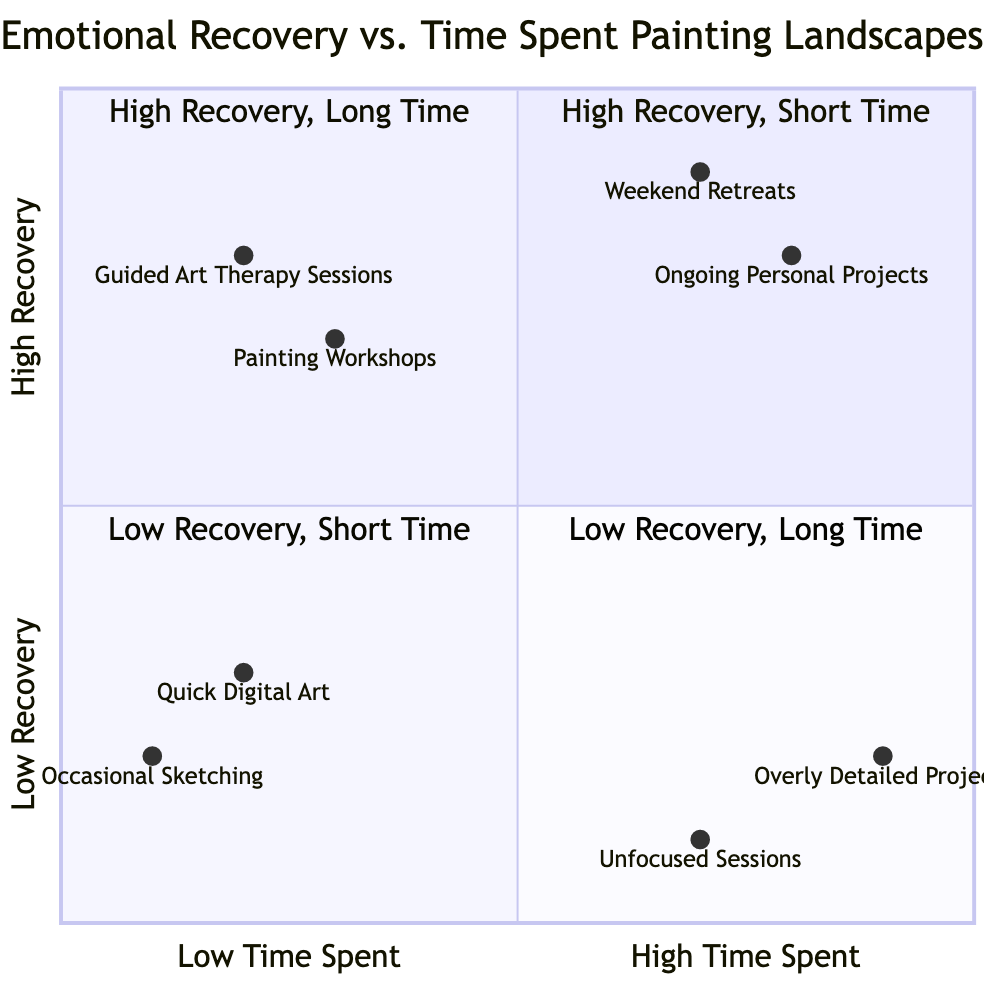What are the two elements in the first quadrant? The first quadrant (Q1) is labeled "High Emotional Recovery, Short Time Spent Painting." The elements listed in this quadrant are "Guided Art Therapy Sessions" and "Painting Workshops."
Answer: Guided Art Therapy Sessions, Painting Workshops Which element has the highest emotional recovery rating? Referring to the quadrants, "Weekend Retreats" has an emotional recovery value of 0.9, which is the highest compared to other elements in the chart.
Answer: Weekend Retreats How many elements are located in the fourth quadrant? The fourth quadrant (Q4) is named "Low Emotional Recovery, Long Time Spent Painting." It contains two elements: "Overly Detailed Projects" and "Unfocused Sessions." Thus, there are two elements in this quadrant.
Answer: 2 In which quadrant does "Occasional Sketching" appear? "Occasional Sketching" is found in the third quadrant (Q3), which is labeled "Low Emotional Recovery, Short Time Spent Painting."
Answer: Third quadrant Is there an element that shows low emotional recovery with a long time spent painting? Yes, the fourth quadrant (Q4) contains elements that exhibit low emotional recovery with a long time spent painting, specifically "Overly Detailed Projects" and "Unfocused Sessions."
Answer: Yes Which element shows the least emotional recovery score? Among all the elements, "Occasional Sketching" has the lowest emotional recovery rating of 0.2, making it the element with the least emotional recovery score.
Answer: Occasional Sketching What is the recovery value of "Ongoing Personal Projects"? "Ongoing Personal Projects" is placed in the second quadrant (Q2) and has a recovery value of 0.8.
Answer: 0.8 Which quadrant would you associate with "Unfocused Sessions"? "Unfocused Sessions" belongs to the fourth quadrant (Q4) which is associated with low emotional recovery and a long time spent painting.
Answer: Fourth quadrant 